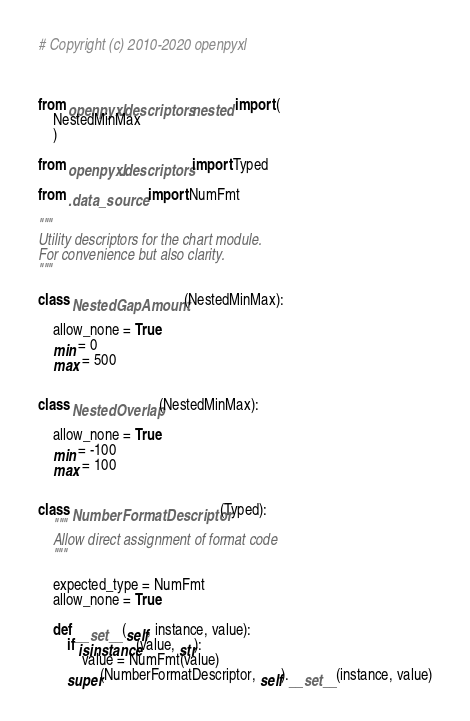Convert code to text. <code><loc_0><loc_0><loc_500><loc_500><_Python_># Copyright (c) 2010-2020 openpyxl



from openpyxl.descriptors.nested import (
    NestedMinMax
    )

from openpyxl.descriptors import Typed

from .data_source import NumFmt

"""
Utility descriptors for the chart module.
For convenience but also clarity.
"""

class NestedGapAmount(NestedMinMax):

    allow_none = True
    min = 0
    max = 500


class NestedOverlap(NestedMinMax):

    allow_none = True
    min = -100
    max = 100


class NumberFormatDescriptor(Typed):
    """
    Allow direct assignment of format code
    """

    expected_type = NumFmt
    allow_none = True

    def __set__(self, instance, value):
        if isinstance(value, str):
            value = NumFmt(value)
        super(NumberFormatDescriptor, self).__set__(instance, value)
</code> 